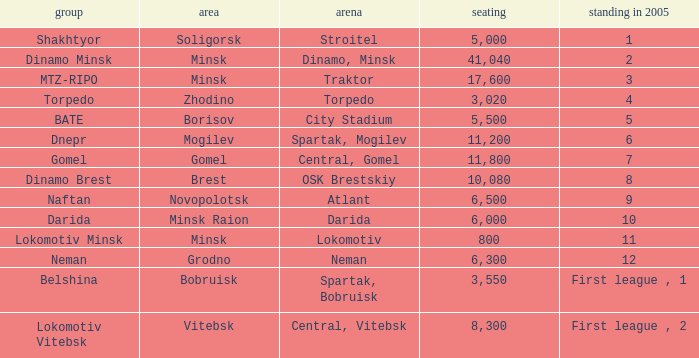Can you tell me the Venue that has the Position in 2005 of 8? OSK Brestskiy. 